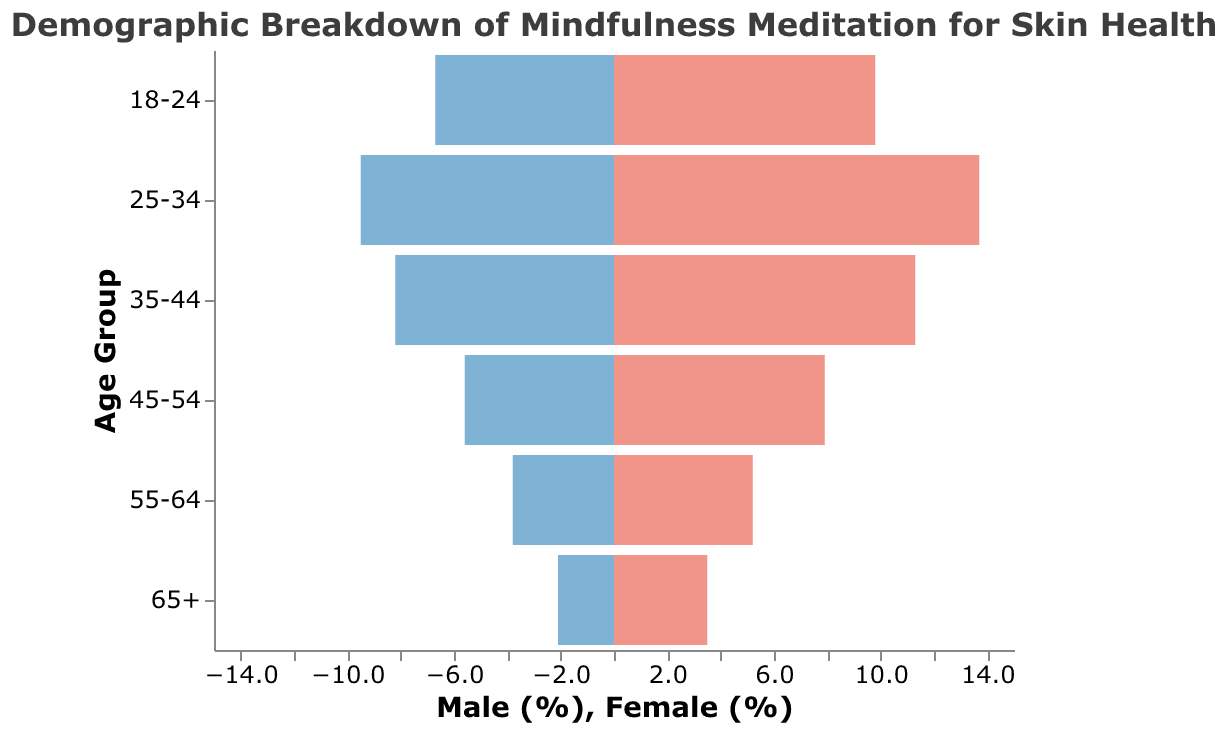What’s the title of the figure? The title is located at the top of the figure and provides an overview of the content. The title text is "Demographic Breakdown of Mindfulness Meditation for Skin Health".
Answer: Demographic Breakdown of Mindfulness Meditation for Skin Health Which age group has the highest percentage of females practicing mindfulness meditation? By examining the lengths of the bars on the right side corresponding to "Female" under the diverse age groups, the age group "25-34" has the highest value at 13.7%.
Answer: 25-34 What percentage of males aged 55-64 practice mindfulness meditation for skin health? Referring to the bar lengths on the left side representing "Male" and finding the bar for the age group "55-64", the label indicates a value of -3.8%.
Answer: 3.8% How much higher is the percentage of females compared to males in the 45-54 age group? The percentage of females in the 45-54 age group is 7.9%, while for males it is 5.6%. The difference is calculated by subtracting the male percentage from the female percentage: 7.9% - 5.6% = 2.3%.
Answer: 2.3% Which age group shows the closest percentage of males practicing mindfulness meditation to 5%? Examining the values on the left side ("Male") and locating the one closest to -5%, the age group "45-54" with a value of -5.6% meets this criterion.
Answer: 45-54 What is the total percentage of people aged 18-24 practicing mindfulness meditation for skin health? The male percentage is 6.7% and the female percentage is 9.8%, summing these values together: 6.7 + 9.8 = 16.5%.
Answer: 16.5% Compare the participation rates in mindfulness meditation between males aged 35-44 and males aged 65+. The percentage of males aged 35-44 is 8.2%, while for males aged 65+ it is 2.1%. By comparing these, 8.2% is significantly higher than 2.1%.
Answer: 35-44 has higher participation What is the average percentage of females practicing mindfulness meditation across all age groups? Adding up all the female percentages: 3.5% + 5.2% + 7.9% + 11.3% + 13.7% + 9.8% = 51.4%. There are 6 age groups, so the average is calculated as 51.4 / 6 = 8.57%.
Answer: 8.57% What is the ratio of females to males in the 25-34 age group practicing mindfulness meditation? For the 25-34 age group: females 13.7% and males 9.5%. The ratio is calculated by dividing the female percentage by the male percentage: 13.7 / 9.5 ≈ 1.44.
Answer: 1.44 